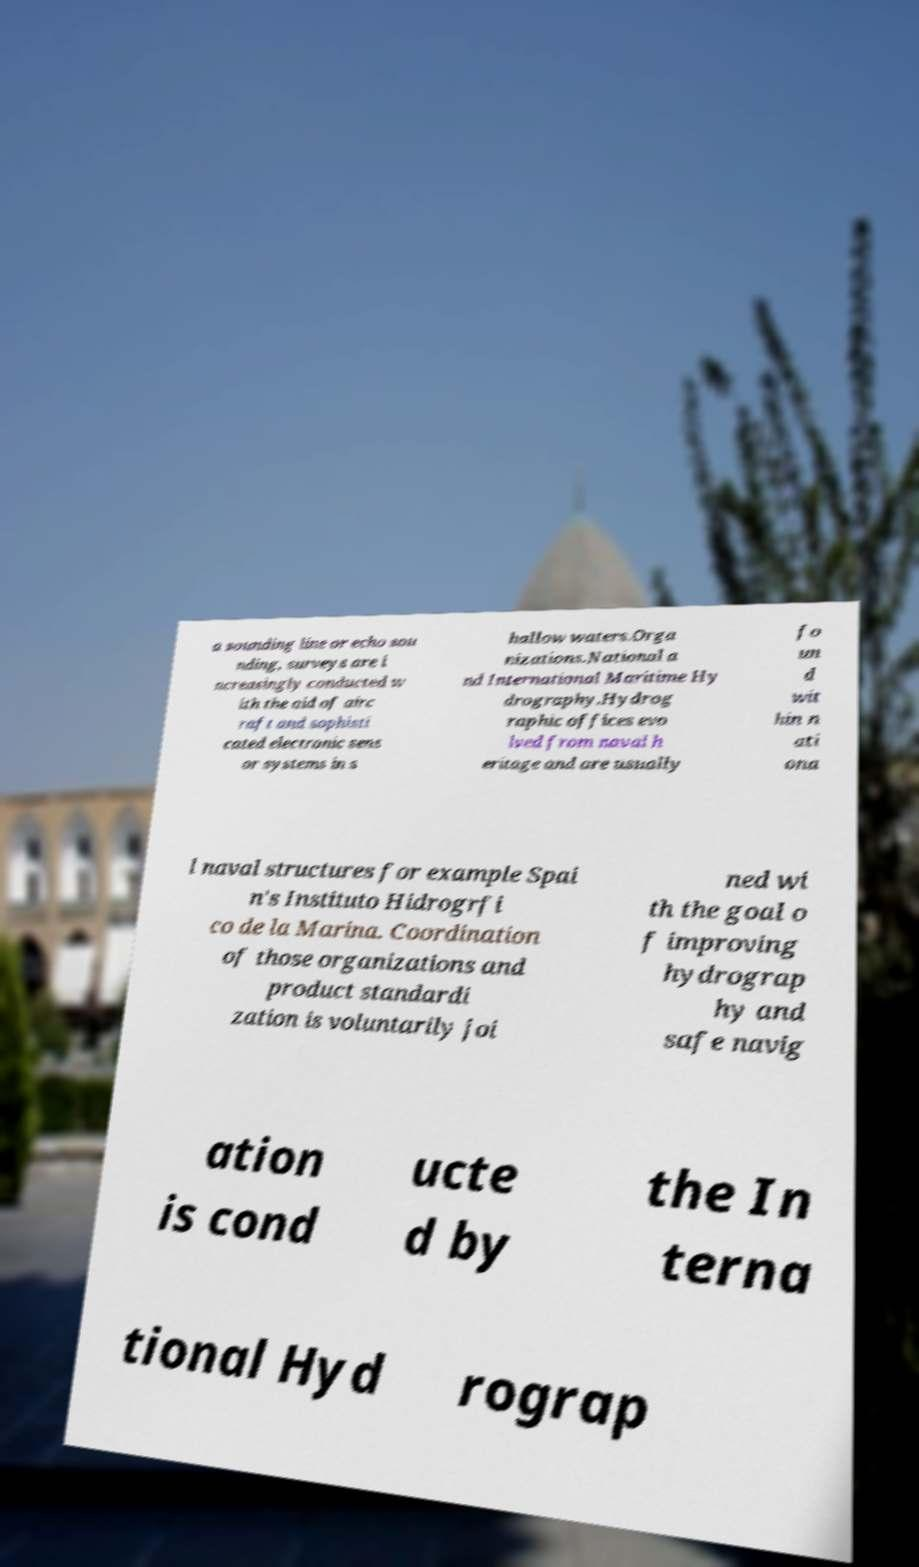Could you extract and type out the text from this image? a sounding line or echo sou nding, surveys are i ncreasingly conducted w ith the aid of airc raft and sophisti cated electronic sens or systems in s hallow waters.Orga nizations.National a nd International Maritime Hy drography.Hydrog raphic offices evo lved from naval h eritage and are usually fo un d wit hin n ati ona l naval structures for example Spai n's Instituto Hidrogrfi co de la Marina. Coordination of those organizations and product standardi zation is voluntarily joi ned wi th the goal o f improving hydrograp hy and safe navig ation is cond ucte d by the In terna tional Hyd rograp 